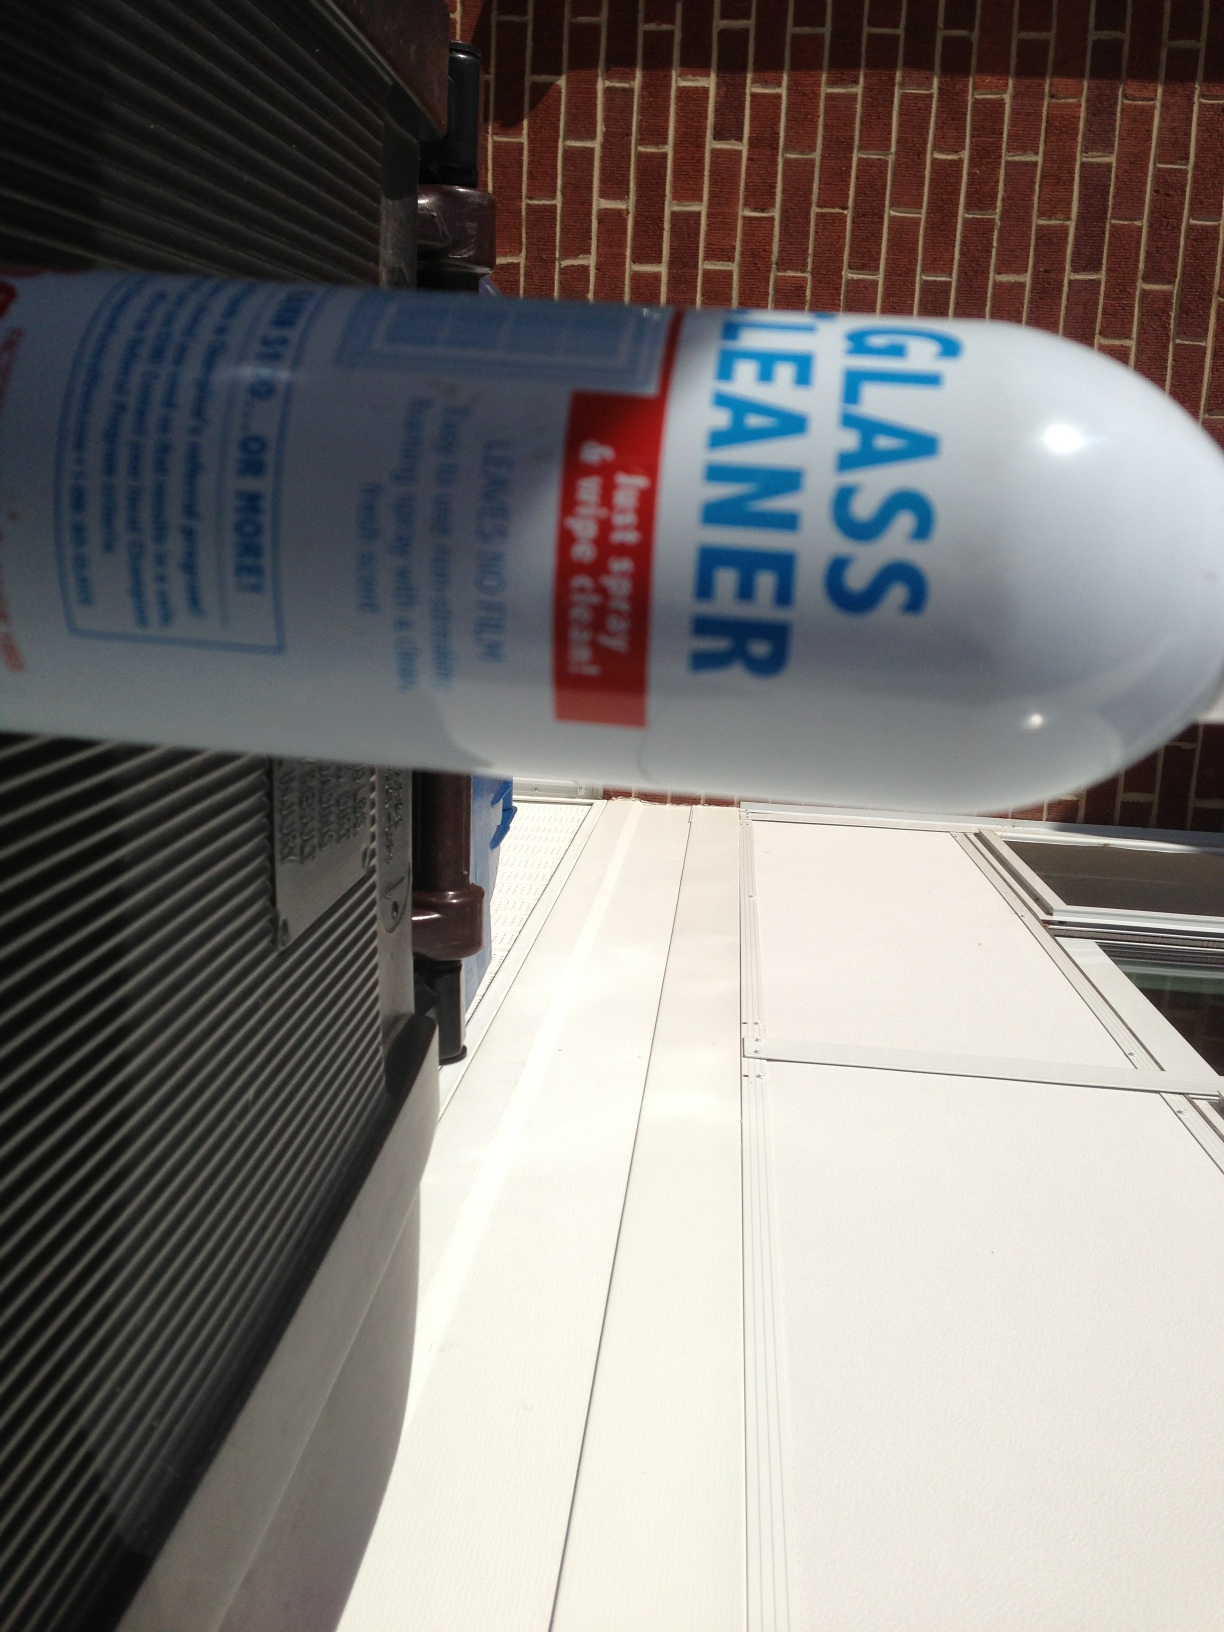What should I do if I accidentally inhale this cleaner? Inhaling fumes from glass cleaners can be harmful, so it's important to use the cleaner in a well-ventilated area. If accidentally inhaled, move to an area with fresh air and breathe normally. If you experience any discomfort, such as coughing or difficulty breathing, seek medical attention promptly. Always keep safety data sheets (SDS) handy for reference in case of accidental inhalation or other emergencies. 